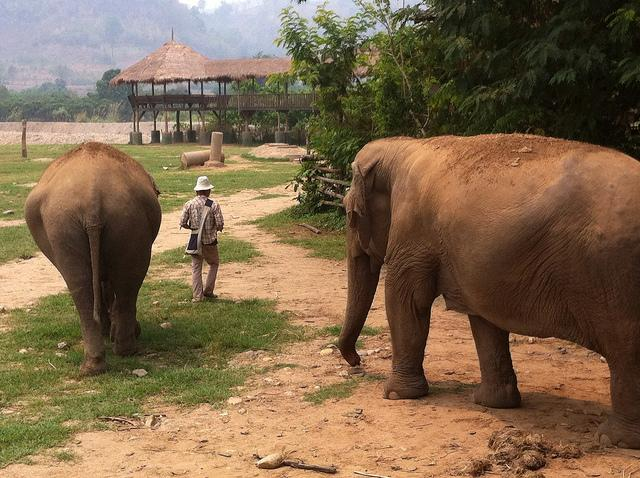How many elephants are following after the man wearing a white hat?

Choices:
A) three
B) four
C) two
D) five two 